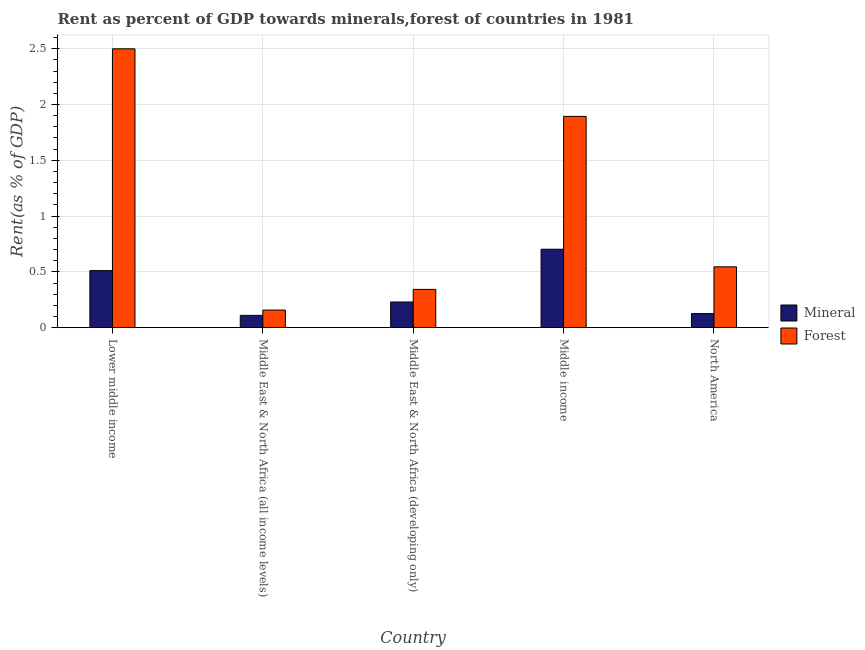How many groups of bars are there?
Your response must be concise. 5. Are the number of bars per tick equal to the number of legend labels?
Keep it short and to the point. Yes. How many bars are there on the 2nd tick from the left?
Provide a short and direct response. 2. What is the label of the 4th group of bars from the left?
Offer a very short reply. Middle income. In how many cases, is the number of bars for a given country not equal to the number of legend labels?
Provide a short and direct response. 0. What is the forest rent in Middle East & North Africa (all income levels)?
Your answer should be compact. 0.16. Across all countries, what is the maximum mineral rent?
Offer a terse response. 0.7. Across all countries, what is the minimum mineral rent?
Give a very brief answer. 0.11. In which country was the forest rent maximum?
Your answer should be compact. Lower middle income. In which country was the mineral rent minimum?
Provide a succinct answer. Middle East & North Africa (all income levels). What is the total forest rent in the graph?
Provide a short and direct response. 5.44. What is the difference between the forest rent in Lower middle income and that in Middle income?
Ensure brevity in your answer.  0.61. What is the difference between the forest rent in Middle income and the mineral rent in Middle East & North Africa (all income levels)?
Provide a short and direct response. 1.78. What is the average forest rent per country?
Offer a terse response. 1.09. What is the difference between the forest rent and mineral rent in Middle East & North Africa (all income levels)?
Your answer should be compact. 0.05. What is the ratio of the forest rent in Lower middle income to that in Middle East & North Africa (developing only)?
Provide a short and direct response. 7.29. Is the forest rent in Middle East & North Africa (developing only) less than that in Middle income?
Make the answer very short. Yes. What is the difference between the highest and the second highest mineral rent?
Provide a short and direct response. 0.19. What is the difference between the highest and the lowest forest rent?
Keep it short and to the point. 2.34. What does the 1st bar from the left in Middle East & North Africa (developing only) represents?
Give a very brief answer. Mineral. What does the 2nd bar from the right in Middle income represents?
Your response must be concise. Mineral. Are all the bars in the graph horizontal?
Your response must be concise. No. How many countries are there in the graph?
Keep it short and to the point. 5. What is the difference between two consecutive major ticks on the Y-axis?
Your response must be concise. 0.5. Are the values on the major ticks of Y-axis written in scientific E-notation?
Give a very brief answer. No. Does the graph contain any zero values?
Give a very brief answer. No. Does the graph contain grids?
Keep it short and to the point. Yes. How many legend labels are there?
Keep it short and to the point. 2. What is the title of the graph?
Ensure brevity in your answer.  Rent as percent of GDP towards minerals,forest of countries in 1981. What is the label or title of the Y-axis?
Provide a short and direct response. Rent(as % of GDP). What is the Rent(as % of GDP) in Mineral in Lower middle income?
Ensure brevity in your answer.  0.51. What is the Rent(as % of GDP) of Forest in Lower middle income?
Offer a very short reply. 2.5. What is the Rent(as % of GDP) of Mineral in Middle East & North Africa (all income levels)?
Offer a terse response. 0.11. What is the Rent(as % of GDP) in Forest in Middle East & North Africa (all income levels)?
Your response must be concise. 0.16. What is the Rent(as % of GDP) of Mineral in Middle East & North Africa (developing only)?
Give a very brief answer. 0.23. What is the Rent(as % of GDP) of Forest in Middle East & North Africa (developing only)?
Provide a short and direct response. 0.34. What is the Rent(as % of GDP) in Mineral in Middle income?
Provide a succinct answer. 0.7. What is the Rent(as % of GDP) of Forest in Middle income?
Offer a very short reply. 1.89. What is the Rent(as % of GDP) of Mineral in North America?
Your answer should be compact. 0.13. What is the Rent(as % of GDP) of Forest in North America?
Keep it short and to the point. 0.55. Across all countries, what is the maximum Rent(as % of GDP) of Mineral?
Offer a very short reply. 0.7. Across all countries, what is the maximum Rent(as % of GDP) in Forest?
Ensure brevity in your answer.  2.5. Across all countries, what is the minimum Rent(as % of GDP) in Mineral?
Ensure brevity in your answer.  0.11. Across all countries, what is the minimum Rent(as % of GDP) of Forest?
Provide a succinct answer. 0.16. What is the total Rent(as % of GDP) of Mineral in the graph?
Provide a short and direct response. 1.68. What is the total Rent(as % of GDP) of Forest in the graph?
Provide a succinct answer. 5.44. What is the difference between the Rent(as % of GDP) in Mineral in Lower middle income and that in Middle East & North Africa (all income levels)?
Your answer should be very brief. 0.4. What is the difference between the Rent(as % of GDP) in Forest in Lower middle income and that in Middle East & North Africa (all income levels)?
Give a very brief answer. 2.34. What is the difference between the Rent(as % of GDP) in Mineral in Lower middle income and that in Middle East & North Africa (developing only)?
Provide a succinct answer. 0.28. What is the difference between the Rent(as % of GDP) of Forest in Lower middle income and that in Middle East & North Africa (developing only)?
Give a very brief answer. 2.16. What is the difference between the Rent(as % of GDP) in Mineral in Lower middle income and that in Middle income?
Offer a terse response. -0.19. What is the difference between the Rent(as % of GDP) of Forest in Lower middle income and that in Middle income?
Your answer should be very brief. 0.61. What is the difference between the Rent(as % of GDP) of Mineral in Lower middle income and that in North America?
Your answer should be compact. 0.39. What is the difference between the Rent(as % of GDP) of Forest in Lower middle income and that in North America?
Provide a short and direct response. 1.95. What is the difference between the Rent(as % of GDP) in Mineral in Middle East & North Africa (all income levels) and that in Middle East & North Africa (developing only)?
Give a very brief answer. -0.12. What is the difference between the Rent(as % of GDP) of Forest in Middle East & North Africa (all income levels) and that in Middle East & North Africa (developing only)?
Offer a terse response. -0.19. What is the difference between the Rent(as % of GDP) of Mineral in Middle East & North Africa (all income levels) and that in Middle income?
Ensure brevity in your answer.  -0.59. What is the difference between the Rent(as % of GDP) of Forest in Middle East & North Africa (all income levels) and that in Middle income?
Your answer should be compact. -1.74. What is the difference between the Rent(as % of GDP) of Mineral in Middle East & North Africa (all income levels) and that in North America?
Ensure brevity in your answer.  -0.02. What is the difference between the Rent(as % of GDP) in Forest in Middle East & North Africa (all income levels) and that in North America?
Your response must be concise. -0.39. What is the difference between the Rent(as % of GDP) in Mineral in Middle East & North Africa (developing only) and that in Middle income?
Make the answer very short. -0.47. What is the difference between the Rent(as % of GDP) in Forest in Middle East & North Africa (developing only) and that in Middle income?
Offer a terse response. -1.55. What is the difference between the Rent(as % of GDP) of Mineral in Middle East & North Africa (developing only) and that in North America?
Your response must be concise. 0.1. What is the difference between the Rent(as % of GDP) of Forest in Middle East & North Africa (developing only) and that in North America?
Your answer should be very brief. -0.2. What is the difference between the Rent(as % of GDP) in Mineral in Middle income and that in North America?
Your response must be concise. 0.58. What is the difference between the Rent(as % of GDP) in Forest in Middle income and that in North America?
Your response must be concise. 1.35. What is the difference between the Rent(as % of GDP) of Mineral in Lower middle income and the Rent(as % of GDP) of Forest in Middle East & North Africa (all income levels)?
Keep it short and to the point. 0.35. What is the difference between the Rent(as % of GDP) of Mineral in Lower middle income and the Rent(as % of GDP) of Forest in Middle East & North Africa (developing only)?
Your answer should be compact. 0.17. What is the difference between the Rent(as % of GDP) in Mineral in Lower middle income and the Rent(as % of GDP) in Forest in Middle income?
Your answer should be very brief. -1.38. What is the difference between the Rent(as % of GDP) in Mineral in Lower middle income and the Rent(as % of GDP) in Forest in North America?
Offer a terse response. -0.03. What is the difference between the Rent(as % of GDP) in Mineral in Middle East & North Africa (all income levels) and the Rent(as % of GDP) in Forest in Middle East & North Africa (developing only)?
Keep it short and to the point. -0.23. What is the difference between the Rent(as % of GDP) of Mineral in Middle East & North Africa (all income levels) and the Rent(as % of GDP) of Forest in Middle income?
Your response must be concise. -1.78. What is the difference between the Rent(as % of GDP) in Mineral in Middle East & North Africa (all income levels) and the Rent(as % of GDP) in Forest in North America?
Your response must be concise. -0.43. What is the difference between the Rent(as % of GDP) in Mineral in Middle East & North Africa (developing only) and the Rent(as % of GDP) in Forest in Middle income?
Provide a succinct answer. -1.66. What is the difference between the Rent(as % of GDP) in Mineral in Middle East & North Africa (developing only) and the Rent(as % of GDP) in Forest in North America?
Provide a succinct answer. -0.32. What is the difference between the Rent(as % of GDP) of Mineral in Middle income and the Rent(as % of GDP) of Forest in North America?
Provide a succinct answer. 0.16. What is the average Rent(as % of GDP) in Mineral per country?
Provide a succinct answer. 0.34. What is the average Rent(as % of GDP) in Forest per country?
Make the answer very short. 1.09. What is the difference between the Rent(as % of GDP) of Mineral and Rent(as % of GDP) of Forest in Lower middle income?
Your response must be concise. -1.99. What is the difference between the Rent(as % of GDP) of Mineral and Rent(as % of GDP) of Forest in Middle East & North Africa (all income levels)?
Your response must be concise. -0.05. What is the difference between the Rent(as % of GDP) of Mineral and Rent(as % of GDP) of Forest in Middle East & North Africa (developing only)?
Provide a succinct answer. -0.11. What is the difference between the Rent(as % of GDP) of Mineral and Rent(as % of GDP) of Forest in Middle income?
Give a very brief answer. -1.19. What is the difference between the Rent(as % of GDP) in Mineral and Rent(as % of GDP) in Forest in North America?
Make the answer very short. -0.42. What is the ratio of the Rent(as % of GDP) of Mineral in Lower middle income to that in Middle East & North Africa (all income levels)?
Keep it short and to the point. 4.64. What is the ratio of the Rent(as % of GDP) in Forest in Lower middle income to that in Middle East & North Africa (all income levels)?
Keep it short and to the point. 15.85. What is the ratio of the Rent(as % of GDP) of Mineral in Lower middle income to that in Middle East & North Africa (developing only)?
Your response must be concise. 2.22. What is the ratio of the Rent(as % of GDP) of Forest in Lower middle income to that in Middle East & North Africa (developing only)?
Offer a very short reply. 7.29. What is the ratio of the Rent(as % of GDP) in Mineral in Lower middle income to that in Middle income?
Provide a short and direct response. 0.73. What is the ratio of the Rent(as % of GDP) of Forest in Lower middle income to that in Middle income?
Make the answer very short. 1.32. What is the ratio of the Rent(as % of GDP) in Mineral in Lower middle income to that in North America?
Ensure brevity in your answer.  4.05. What is the ratio of the Rent(as % of GDP) of Forest in Lower middle income to that in North America?
Ensure brevity in your answer.  4.58. What is the ratio of the Rent(as % of GDP) of Mineral in Middle East & North Africa (all income levels) to that in Middle East & North Africa (developing only)?
Give a very brief answer. 0.48. What is the ratio of the Rent(as % of GDP) in Forest in Middle East & North Africa (all income levels) to that in Middle East & North Africa (developing only)?
Provide a short and direct response. 0.46. What is the ratio of the Rent(as % of GDP) of Mineral in Middle East & North Africa (all income levels) to that in Middle income?
Your answer should be compact. 0.16. What is the ratio of the Rent(as % of GDP) in Forest in Middle East & North Africa (all income levels) to that in Middle income?
Your response must be concise. 0.08. What is the ratio of the Rent(as % of GDP) in Mineral in Middle East & North Africa (all income levels) to that in North America?
Give a very brief answer. 0.87. What is the ratio of the Rent(as % of GDP) in Forest in Middle East & North Africa (all income levels) to that in North America?
Provide a short and direct response. 0.29. What is the ratio of the Rent(as % of GDP) in Mineral in Middle East & North Africa (developing only) to that in Middle income?
Offer a very short reply. 0.33. What is the ratio of the Rent(as % of GDP) in Forest in Middle East & North Africa (developing only) to that in Middle income?
Provide a short and direct response. 0.18. What is the ratio of the Rent(as % of GDP) in Mineral in Middle East & North Africa (developing only) to that in North America?
Provide a succinct answer. 1.82. What is the ratio of the Rent(as % of GDP) of Forest in Middle East & North Africa (developing only) to that in North America?
Make the answer very short. 0.63. What is the ratio of the Rent(as % of GDP) in Mineral in Middle income to that in North America?
Offer a very short reply. 5.57. What is the ratio of the Rent(as % of GDP) of Forest in Middle income to that in North America?
Your response must be concise. 3.47. What is the difference between the highest and the second highest Rent(as % of GDP) in Mineral?
Make the answer very short. 0.19. What is the difference between the highest and the second highest Rent(as % of GDP) in Forest?
Make the answer very short. 0.61. What is the difference between the highest and the lowest Rent(as % of GDP) of Mineral?
Make the answer very short. 0.59. What is the difference between the highest and the lowest Rent(as % of GDP) in Forest?
Your answer should be compact. 2.34. 